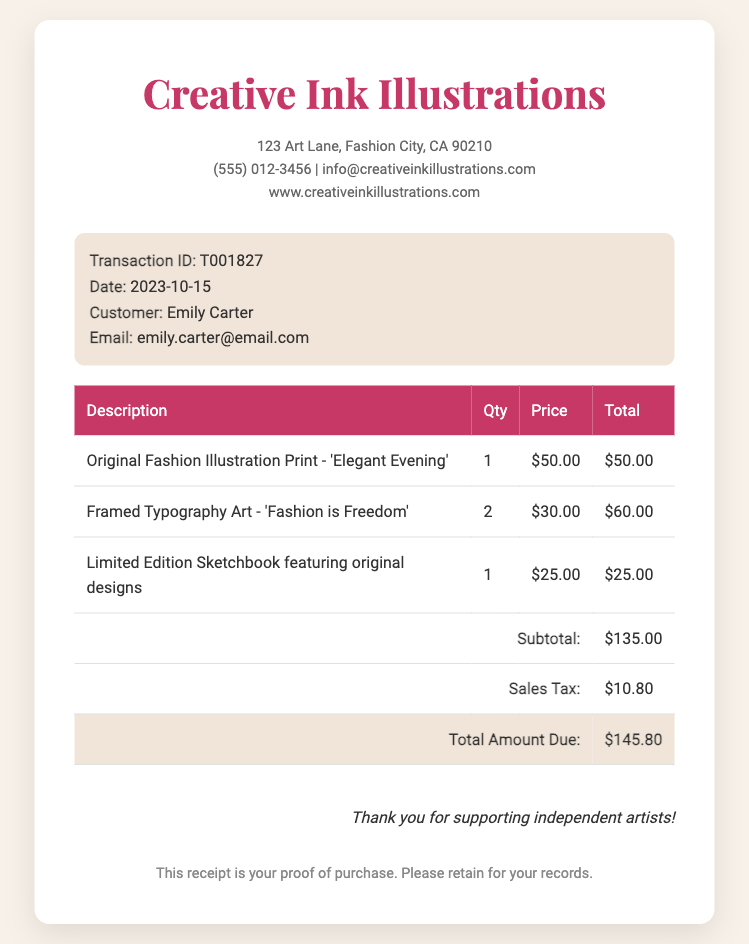What is the name of the customer? The document identifies the customer as Emily Carter.
Answer: Emily Carter What is the transaction ID? The transaction ID listed in the document is T001827.
Answer: T001827 What is the total amount due? The total amount due from the document is clearly stated as $145.80.
Answer: $145.80 How many framed typography art pieces were purchased? The document shows that 2 pieces of framed typography art were purchased.
Answer: 2 What is the sales tax amount? The sales tax amount listed in the document is $10.80.
Answer: $10.80 What is the date of the transaction? The date provided for this transaction is 2023-10-15.
Answer: 2023-10-15 What is the price of the limited edition sketchbook? The document specifies the price of the limited edition sketchbook as $25.00.
Answer: $25.00 What item has the title 'Elegant Evening'? The document mentions this as the title for the original fashion illustration print.
Answer: Original Fashion Illustration Print - 'Elegant Evening' What is the subtotal before sales tax? The subtotal before sales tax is indicated as $135.00 in the document.
Answer: $135.00 